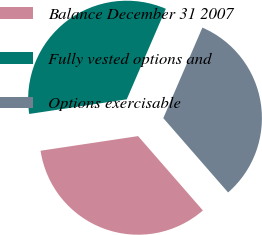<chart> <loc_0><loc_0><loc_500><loc_500><pie_chart><fcel>Balance December 31 2007<fcel>Fully vested options and<fcel>Options exercisable<nl><fcel>34.04%<fcel>33.86%<fcel>32.1%<nl></chart> 